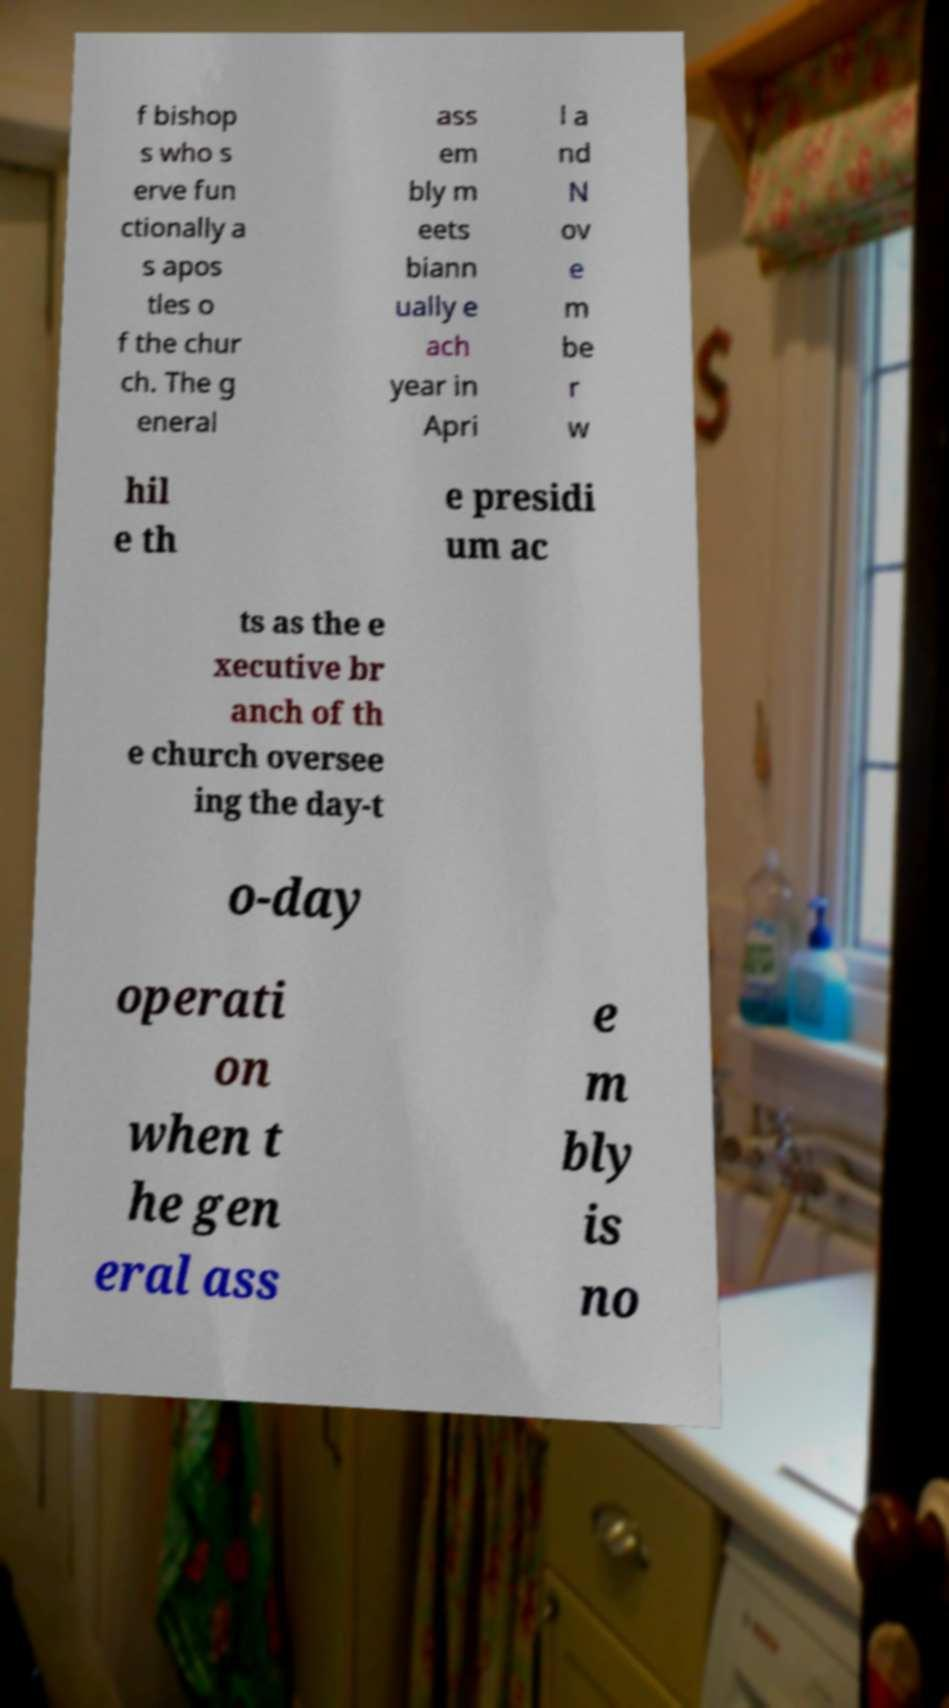Could you extract and type out the text from this image? f bishop s who s erve fun ctionally a s apos tles o f the chur ch. The g eneral ass em bly m eets biann ually e ach year in Apri l a nd N ov e m be r w hil e th e presidi um ac ts as the e xecutive br anch of th e church oversee ing the day-t o-day operati on when t he gen eral ass e m bly is no 